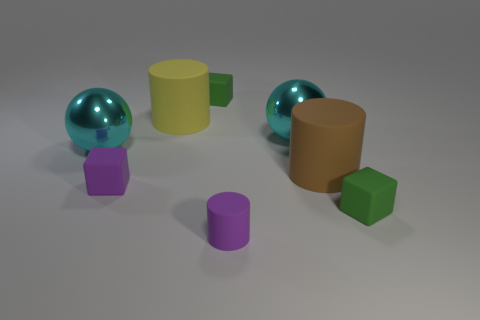Add 2 small rubber cylinders. How many objects exist? 10 Subtract all balls. How many objects are left? 6 Add 5 big cyan spheres. How many big cyan spheres exist? 7 Subtract 0 red cylinders. How many objects are left? 8 Subtract all big things. Subtract all red matte cylinders. How many objects are left? 4 Add 8 brown rubber objects. How many brown rubber objects are left? 9 